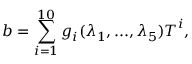<formula> <loc_0><loc_0><loc_500><loc_500>b = \sum _ { i = 1 } ^ { 1 0 } g _ { i } ( \lambda _ { 1 } , \dots , \lambda _ { 5 } ) T ^ { i } ,</formula> 